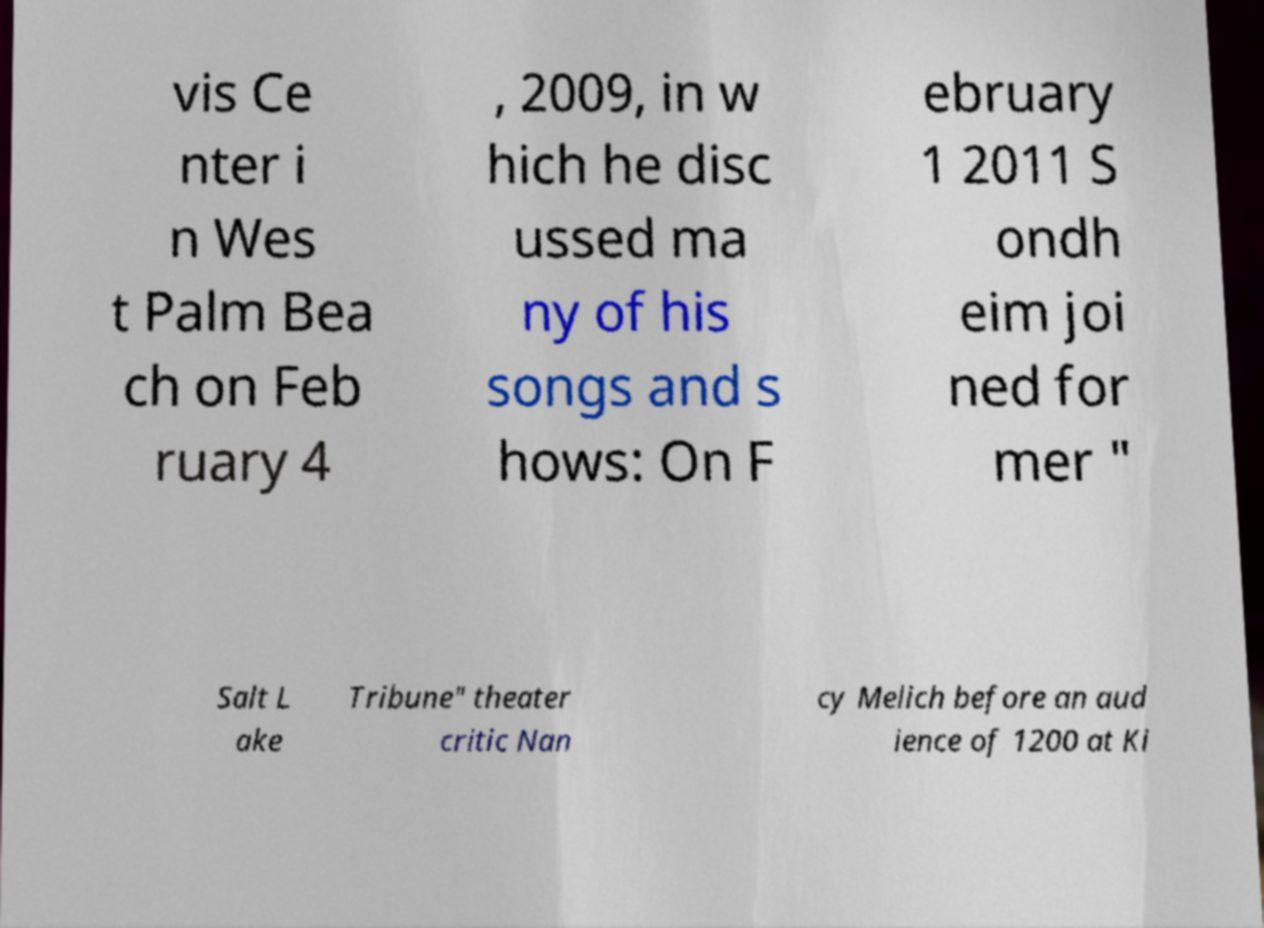Please identify and transcribe the text found in this image. vis Ce nter i n Wes t Palm Bea ch on Feb ruary 4 , 2009, in w hich he disc ussed ma ny of his songs and s hows: On F ebruary 1 2011 S ondh eim joi ned for mer " Salt L ake Tribune" theater critic Nan cy Melich before an aud ience of 1200 at Ki 